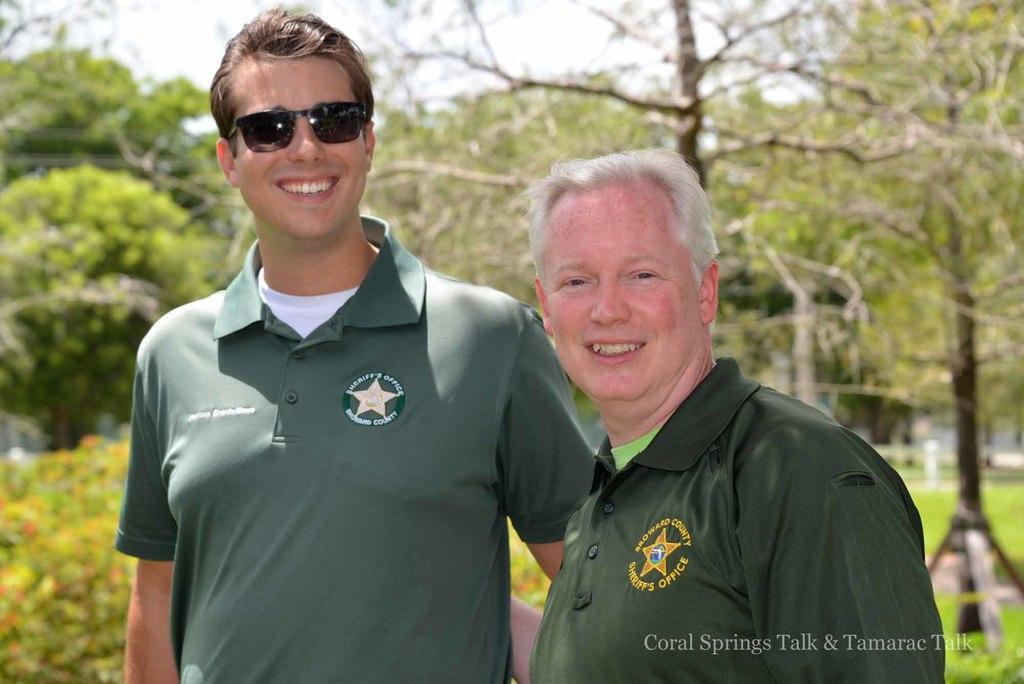Please provide a concise description of this image. In this image in the front there are persons standing and smiling. In the background there are trees and there's grass on the ground and at the bottom right of the image there is some text written on it. 